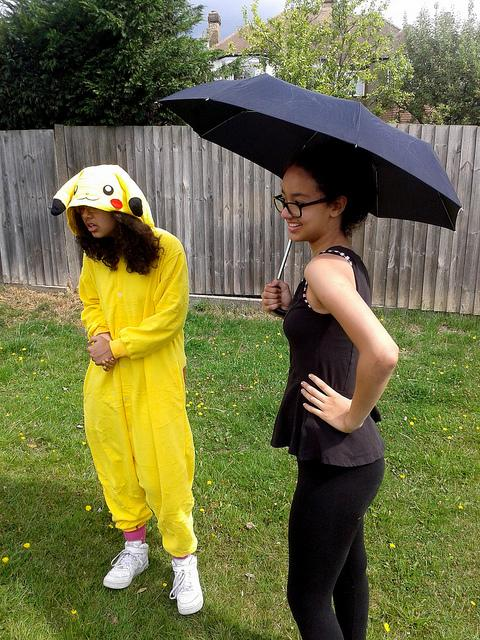What do the girls use the umbrella to avoid in this situation? Please explain your reasoning. sunburn. Umbrellas can be used to protect from uv rays. the girls do not want to get skins cancer. 